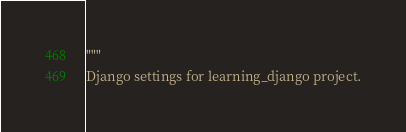<code> <loc_0><loc_0><loc_500><loc_500><_Python_>"""
Django settings for learning_django project.
</code> 